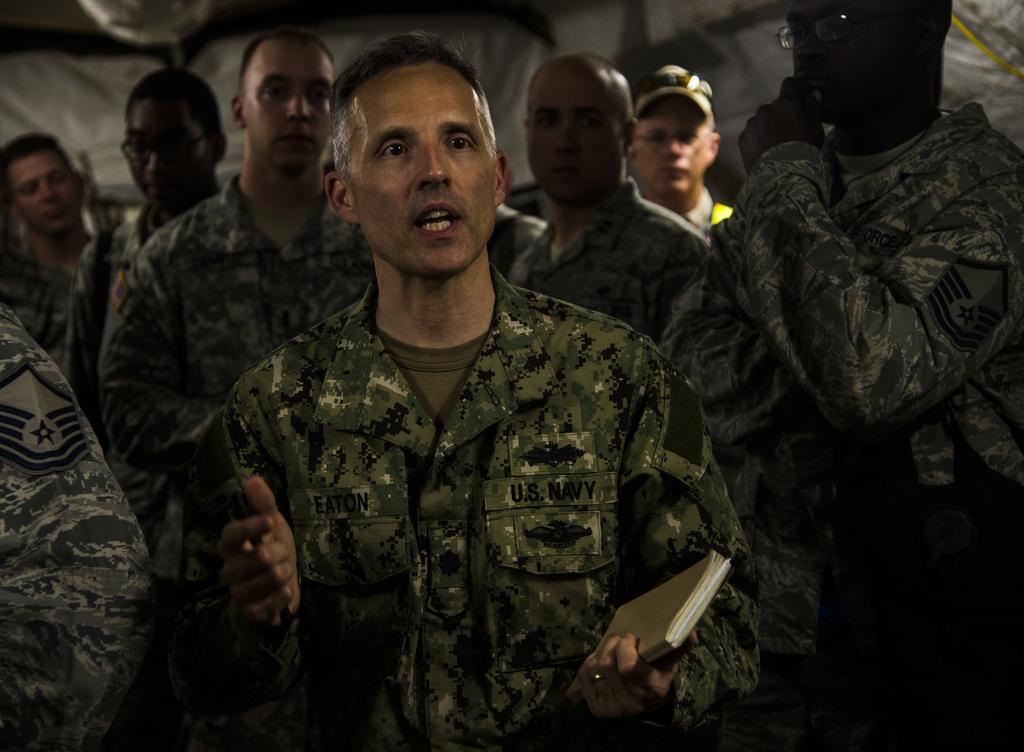Can you describe this image briefly? In this image we can see people standing. They are all wearing uniforms. The man standing in the center is holding a book. 